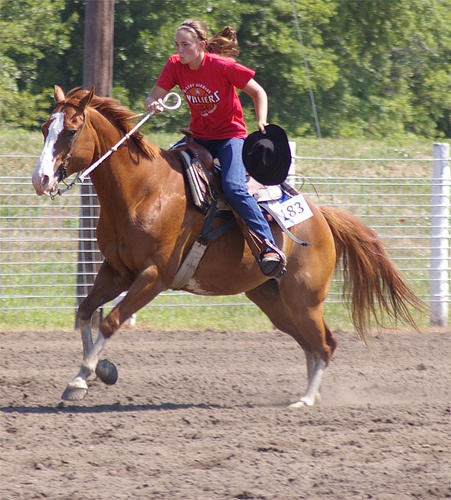Describe the objects in this image and their specific colors. I can see horse in tan, maroon, gray, and black tones and people in tan, brown, maroon, and black tones in this image. 